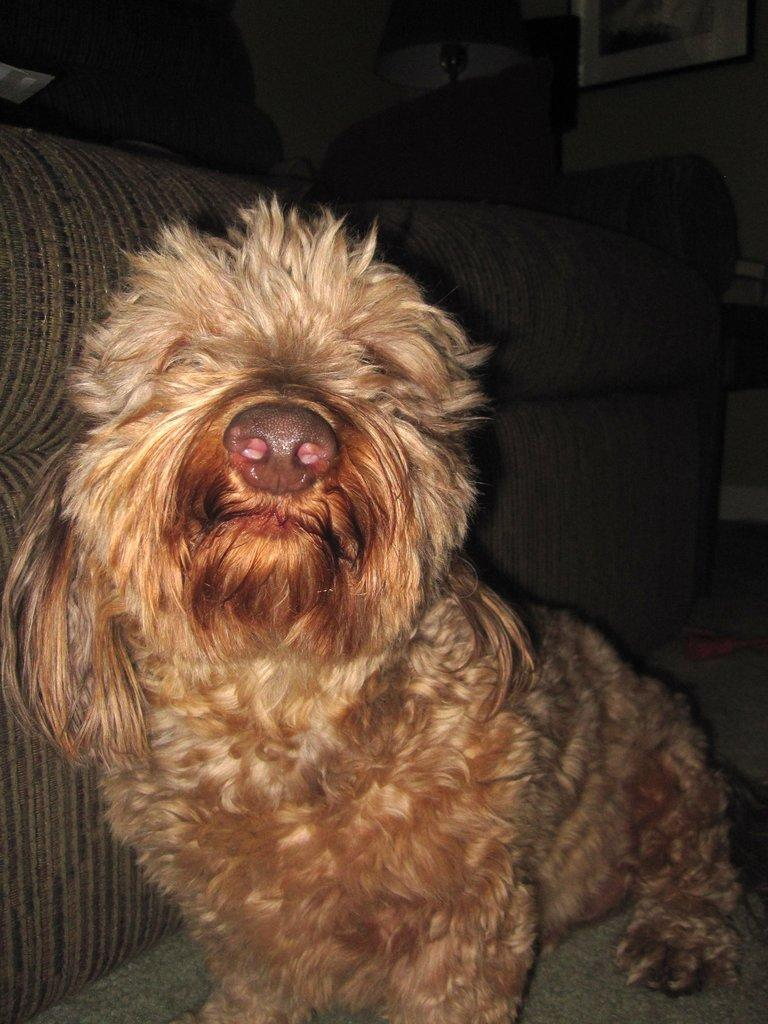What animal is sitting in the image? There is a dog sitting in the image. What piece of furniture is on the left side of the image? There is a sofa on the left side of the image. What objects can be seen in the background of the image? There is a lamp and a photo frame in the background of the image. What type of tree is growing in the background of the image? There is no tree present in the background of the image. What class is the dog attending in the image? The image does not depict a class or any educational setting, so it is not possible to determine the dog's class. 